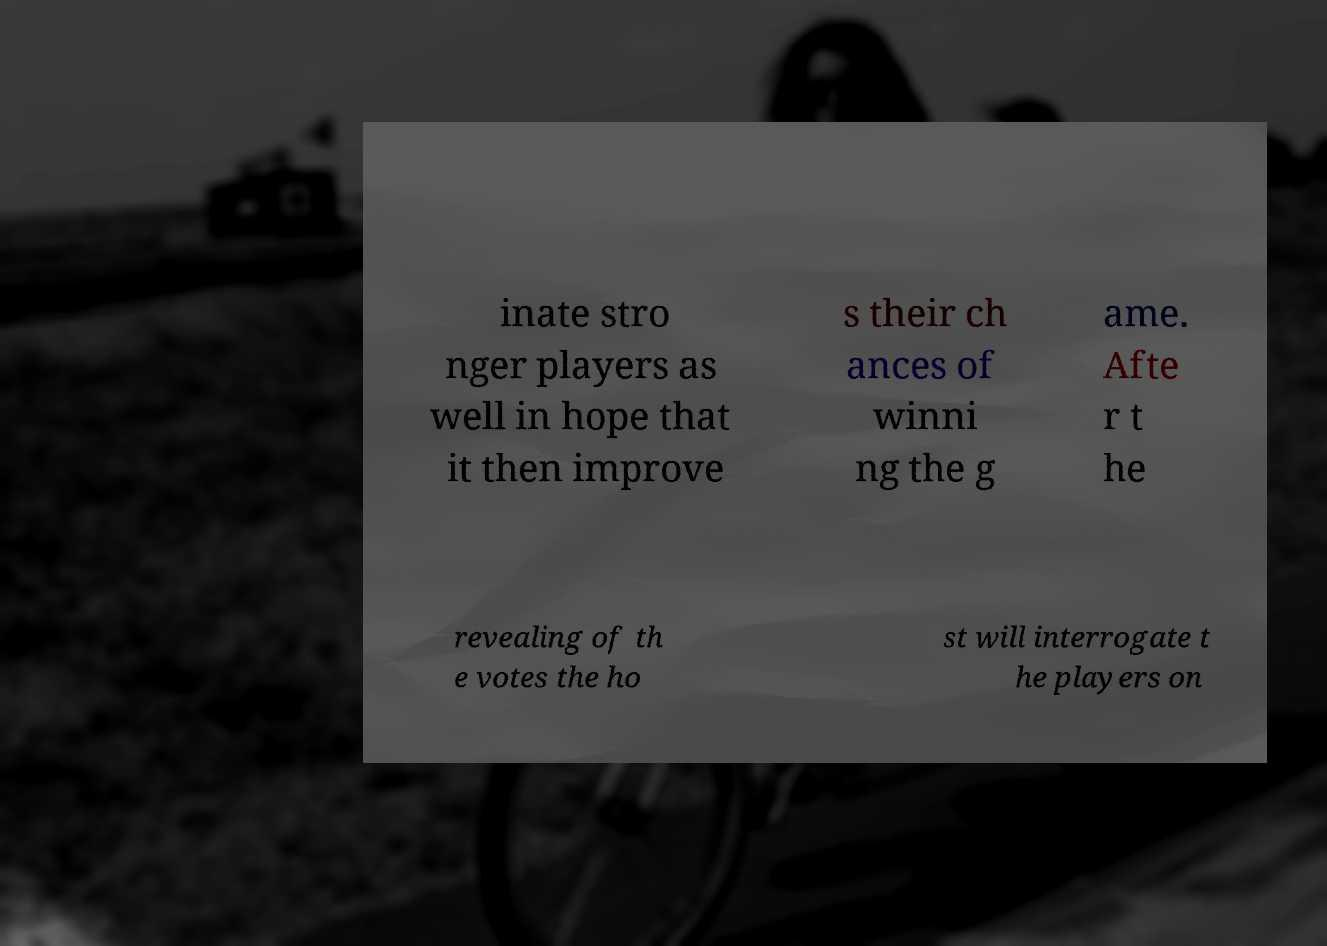Please identify and transcribe the text found in this image. inate stro nger players as well in hope that it then improve s their ch ances of winni ng the g ame. Afte r t he revealing of th e votes the ho st will interrogate t he players on 